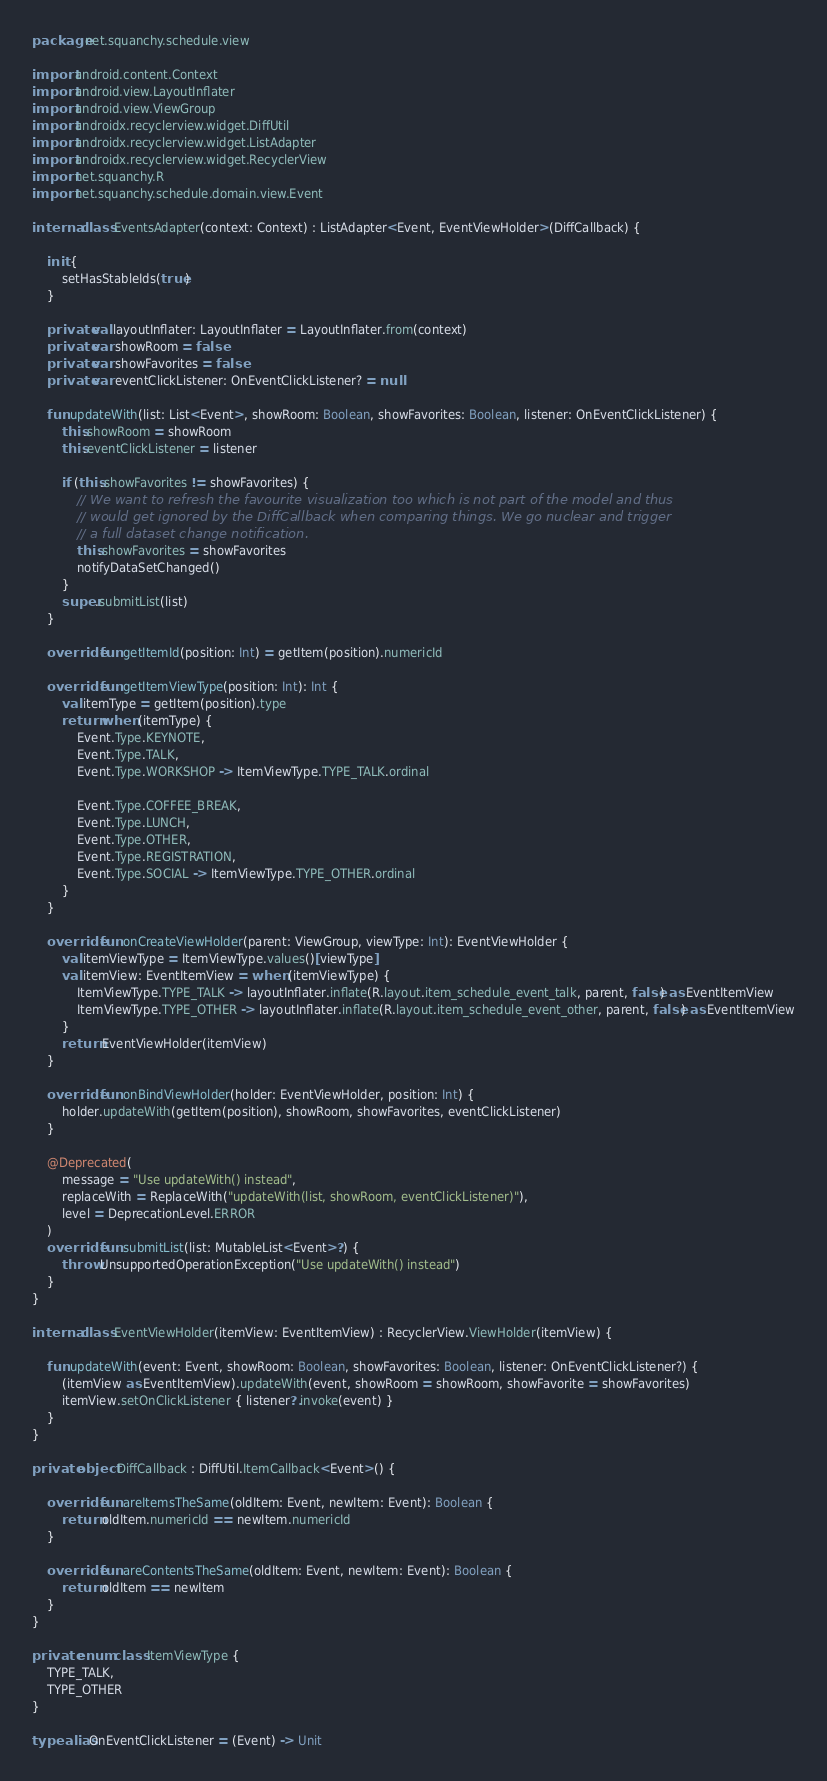<code> <loc_0><loc_0><loc_500><loc_500><_Kotlin_>package net.squanchy.schedule.view

import android.content.Context
import android.view.LayoutInflater
import android.view.ViewGroup
import androidx.recyclerview.widget.DiffUtil
import androidx.recyclerview.widget.ListAdapter
import androidx.recyclerview.widget.RecyclerView
import net.squanchy.R
import net.squanchy.schedule.domain.view.Event

internal class EventsAdapter(context: Context) : ListAdapter<Event, EventViewHolder>(DiffCallback) {

    init {
        setHasStableIds(true)
    }

    private val layoutInflater: LayoutInflater = LayoutInflater.from(context)
    private var showRoom = false
    private var showFavorites = false
    private var eventClickListener: OnEventClickListener? = null

    fun updateWith(list: List<Event>, showRoom: Boolean, showFavorites: Boolean, listener: OnEventClickListener) {
        this.showRoom = showRoom
        this.eventClickListener = listener

        if (this.showFavorites != showFavorites) {
            // We want to refresh the favourite visualization too which is not part of the model and thus
            // would get ignored by the DiffCallback when comparing things. We go nuclear and trigger
            // a full dataset change notification.
            this.showFavorites = showFavorites
            notifyDataSetChanged()
        }
        super.submitList(list)
    }

    override fun getItemId(position: Int) = getItem(position).numericId

    override fun getItemViewType(position: Int): Int {
        val itemType = getItem(position).type
        return when (itemType) {
            Event.Type.KEYNOTE,
            Event.Type.TALK,
            Event.Type.WORKSHOP -> ItemViewType.TYPE_TALK.ordinal

            Event.Type.COFFEE_BREAK,
            Event.Type.LUNCH,
            Event.Type.OTHER,
            Event.Type.REGISTRATION,
            Event.Type.SOCIAL -> ItemViewType.TYPE_OTHER.ordinal
        }
    }

    override fun onCreateViewHolder(parent: ViewGroup, viewType: Int): EventViewHolder {
        val itemViewType = ItemViewType.values()[viewType]
        val itemView: EventItemView = when (itemViewType) {
            ItemViewType.TYPE_TALK -> layoutInflater.inflate(R.layout.item_schedule_event_talk, parent, false) as EventItemView
            ItemViewType.TYPE_OTHER -> layoutInflater.inflate(R.layout.item_schedule_event_other, parent, false) as EventItemView
        }
        return EventViewHolder(itemView)
    }

    override fun onBindViewHolder(holder: EventViewHolder, position: Int) {
        holder.updateWith(getItem(position), showRoom, showFavorites, eventClickListener)
    }

    @Deprecated(
        message = "Use updateWith() instead",
        replaceWith = ReplaceWith("updateWith(list, showRoom, eventClickListener)"),
        level = DeprecationLevel.ERROR
    )
    override fun submitList(list: MutableList<Event>?) {
        throw UnsupportedOperationException("Use updateWith() instead")
    }
}

internal class EventViewHolder(itemView: EventItemView) : RecyclerView.ViewHolder(itemView) {

    fun updateWith(event: Event, showRoom: Boolean, showFavorites: Boolean, listener: OnEventClickListener?) {
        (itemView as EventItemView).updateWith(event, showRoom = showRoom, showFavorite = showFavorites)
        itemView.setOnClickListener { listener?.invoke(event) }
    }
}

private object DiffCallback : DiffUtil.ItemCallback<Event>() {

    override fun areItemsTheSame(oldItem: Event, newItem: Event): Boolean {
        return oldItem.numericId == newItem.numericId
    }

    override fun areContentsTheSame(oldItem: Event, newItem: Event): Boolean {
        return oldItem == newItem
    }
}

private enum class ItemViewType {
    TYPE_TALK,
    TYPE_OTHER
}

typealias OnEventClickListener = (Event) -> Unit
</code> 